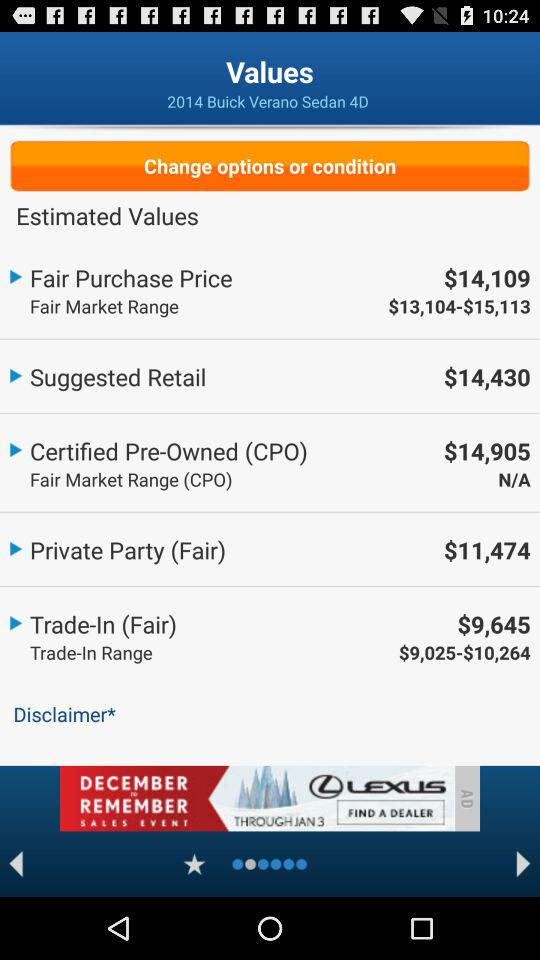What is the trade-in (fair) price? The trade-in (fair) price is $9,645. 